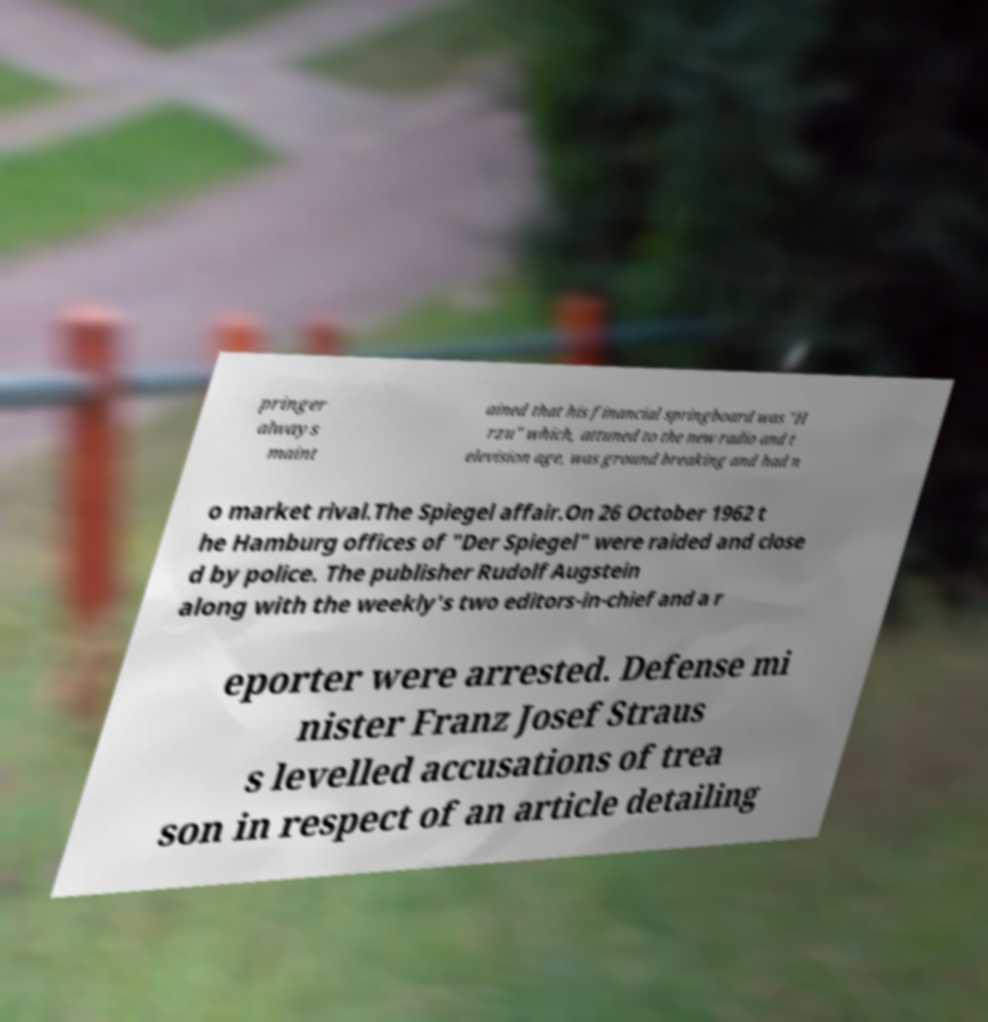For documentation purposes, I need the text within this image transcribed. Could you provide that? pringer always maint ained that his financial springboard was "H rzu" which, attuned to the new radio and t elevision age, was ground breaking and had n o market rival.The Spiegel affair.On 26 October 1962 t he Hamburg offices of "Der Spiegel" were raided and close d by police. The publisher Rudolf Augstein along with the weekly's two editors-in-chief and a r eporter were arrested. Defense mi nister Franz Josef Straus s levelled accusations of trea son in respect of an article detailing 